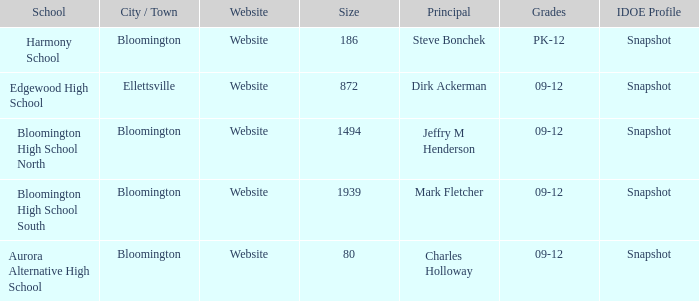Where's the school that Mark Fletcher is the principal of? Bloomington. 